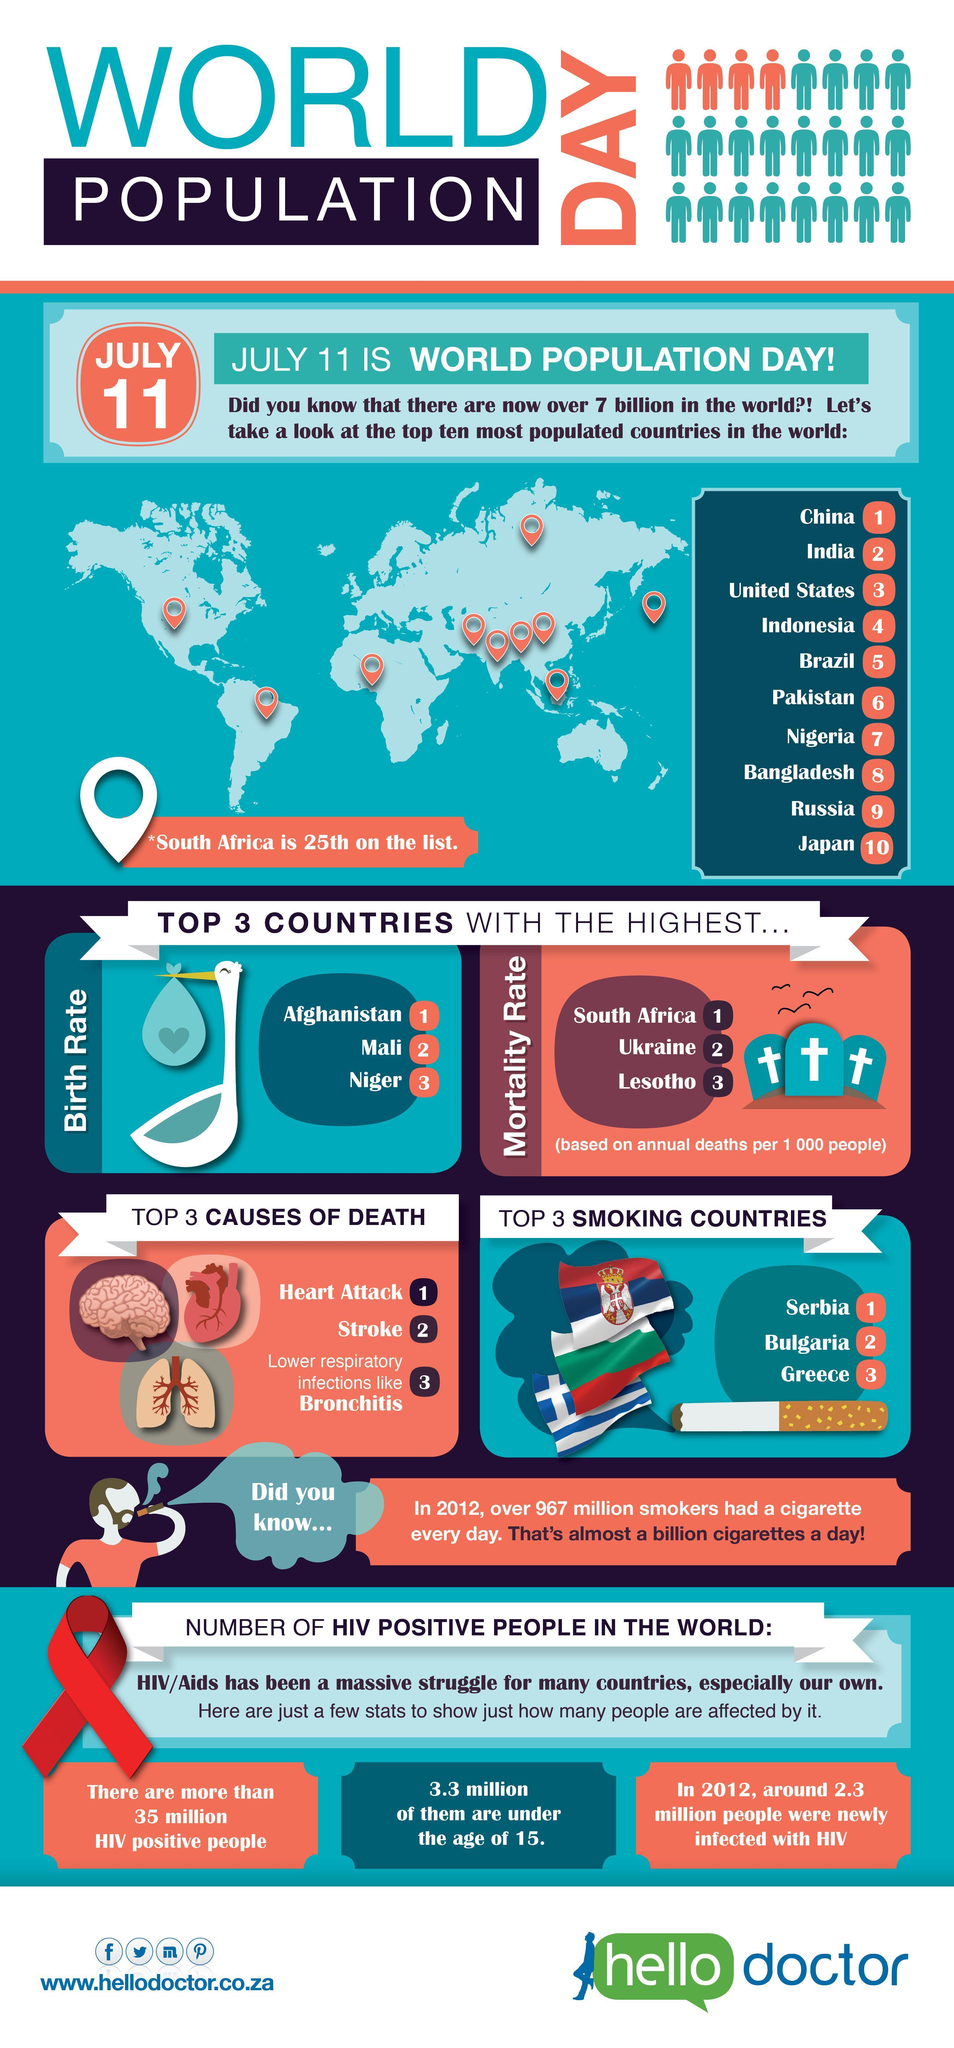What is the total number of countries with the highest birth rate and mortality rate, taken together?
Answer the question with a short phrase. 6 